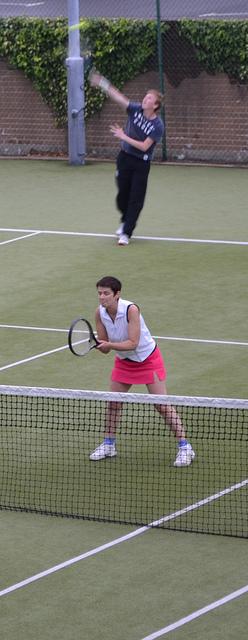What sport is this?
Give a very brief answer. Tennis. Why is the woman in the foreground not moving?
Give a very brief answer. Waiting. What color is the court's floor?
Write a very short answer. Green. 